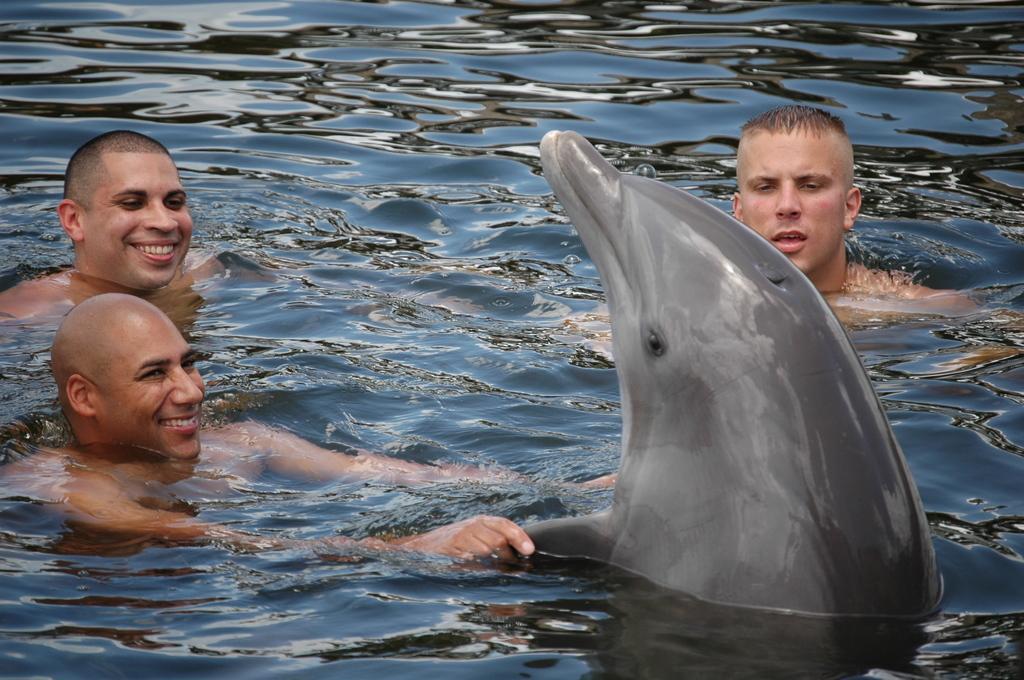Can you describe this image briefly? There are three persons in the water. The first is holding the wings of the dolphin and he is smiling, Second person is looking to the dolphin and smiling, the third person is looking to the dolphin. 